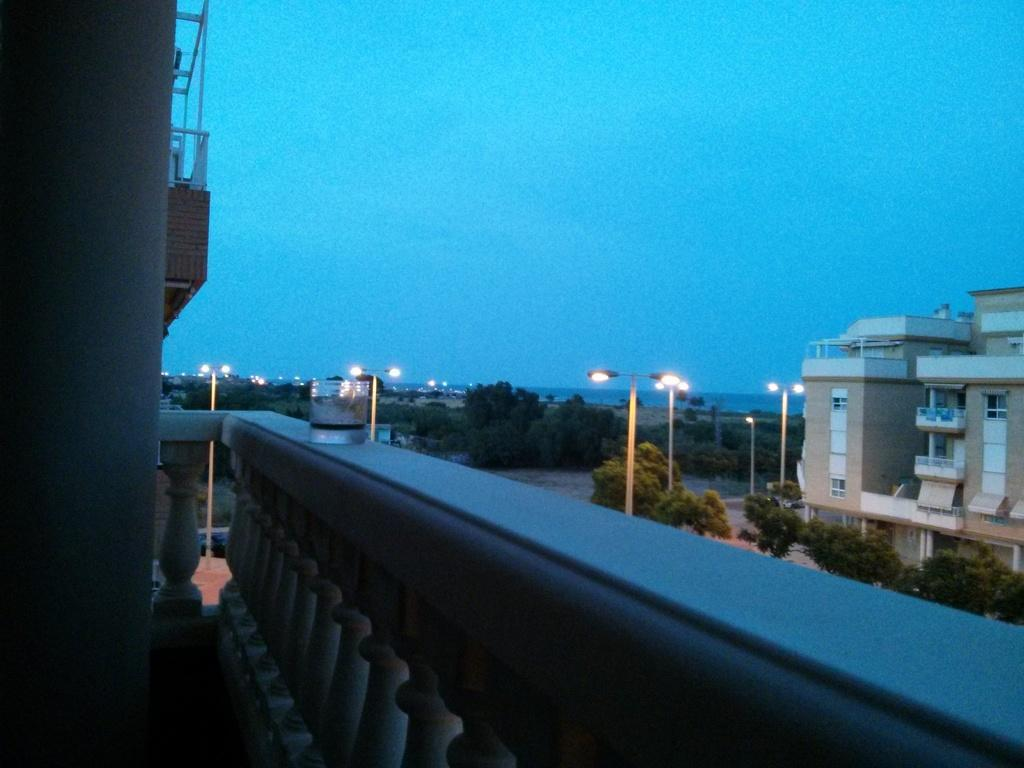What object is placed on the fence in the image? There is a glass placed on a fence in the image. What type of vegetation can be seen in the image? Trees are visible in the image. What type of artificial lighting is present in the image? Street lights are present in the image. What type of structure can be seen in the image? There is a building with windows in the image. What is the condition of the sky in the image? The sky is visible in the image and appears cloudy. How many screws can be seen holding the building together in the image? There are no screws visible in the image; the building's construction is not shown in detail. What type of natural disaster is occurring in the image? There is no indication of any natural disaster, such as an earthquake, in the image. 